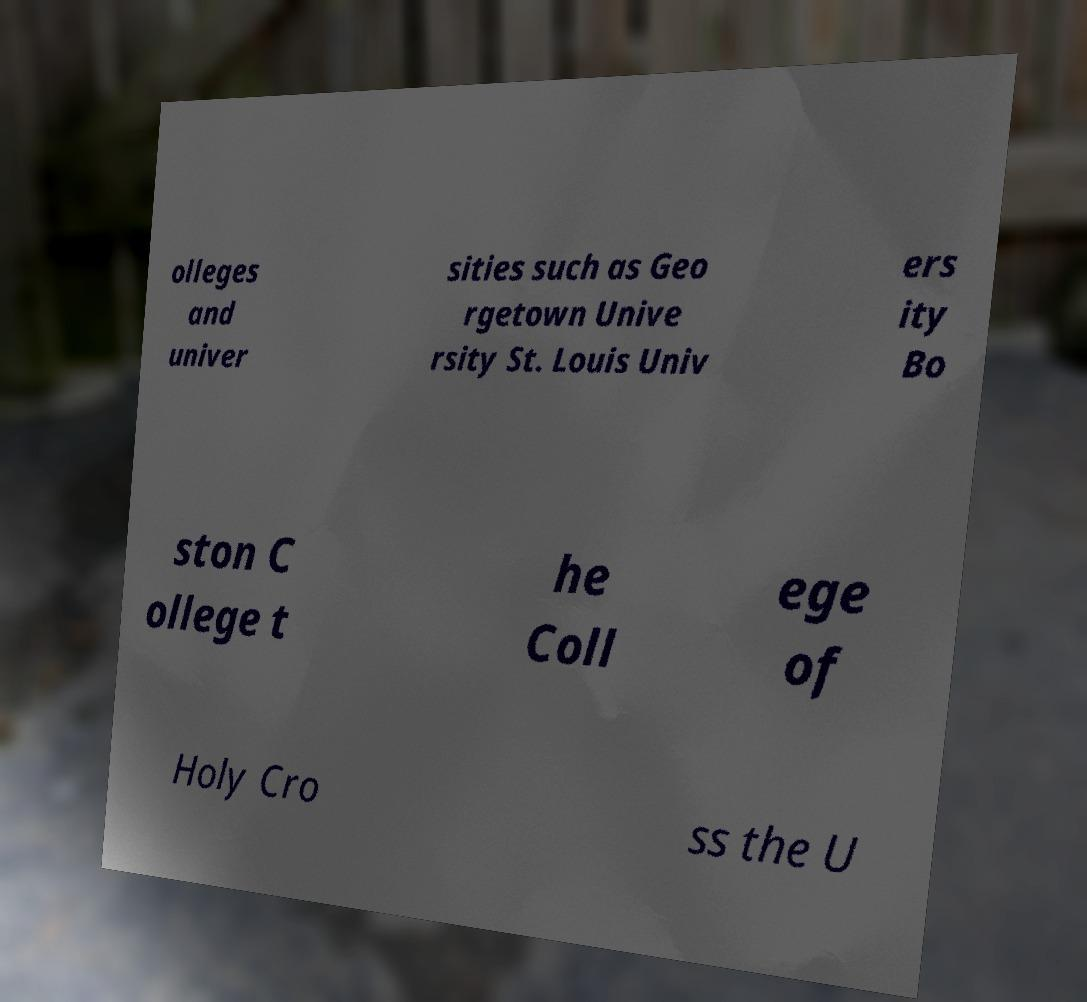Please read and relay the text visible in this image. What does it say? olleges and univer sities such as Geo rgetown Unive rsity St. Louis Univ ers ity Bo ston C ollege t he Coll ege of Holy Cro ss the U 